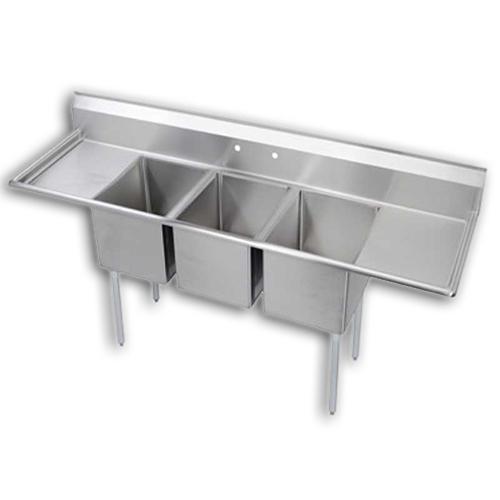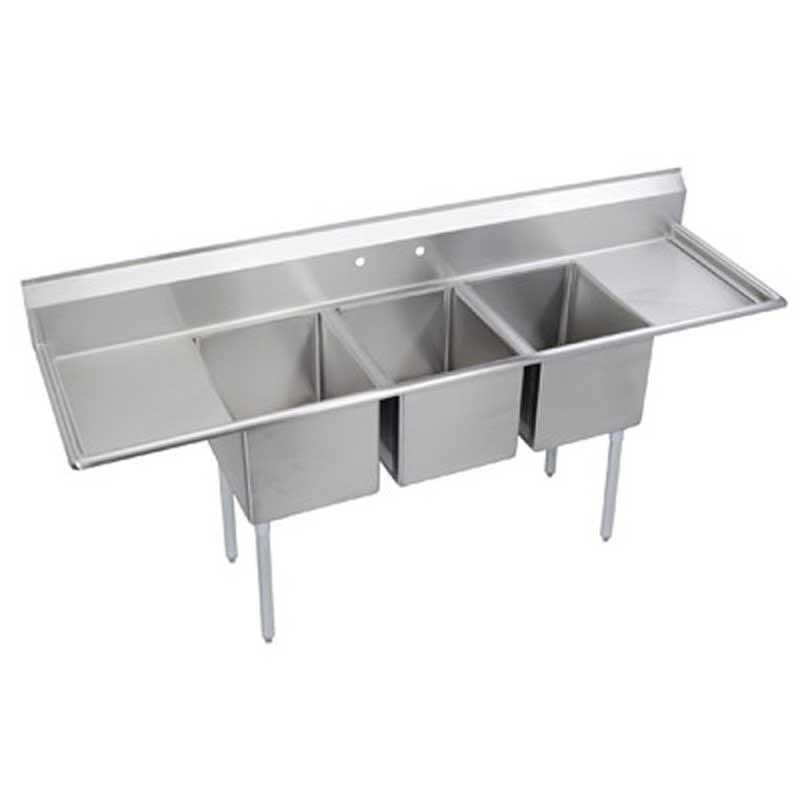The first image is the image on the left, the second image is the image on the right. Considering the images on both sides, is "Each image contains a three part sink without a faucet" valid? Answer yes or no. Yes. 